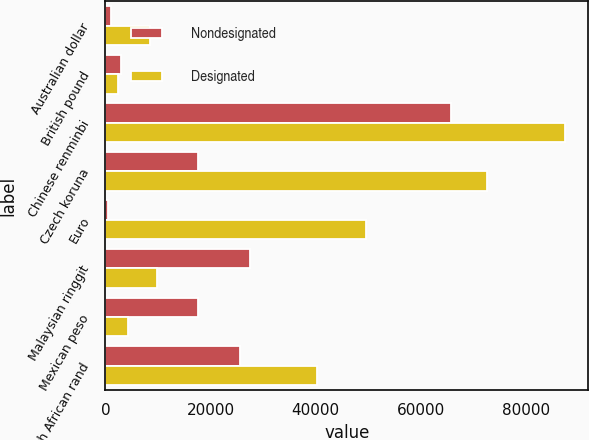<chart> <loc_0><loc_0><loc_500><loc_500><stacked_bar_chart><ecel><fcel>Australian dollar<fcel>British pound<fcel>Chinese renminbi<fcel>Czech koruna<fcel>Euro<fcel>Malaysian ringgit<fcel>Mexican peso<fcel>South African rand<nl><fcel>Nondesignated<fcel>1125<fcel>3005<fcel>65660<fcel>17670<fcel>492<fcel>27513<fcel>17670<fcel>25625<nl><fcel>Designated<fcel>8550<fcel>2463<fcel>87427<fcel>72527<fcel>49496<fcel>9715<fcel>4304<fcel>40193<nl></chart> 